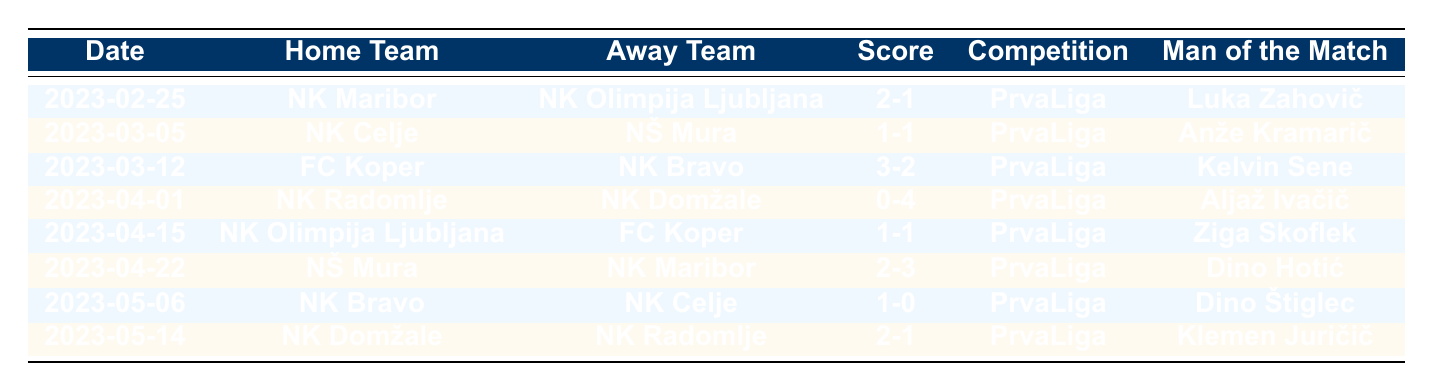What was the date of the match between NK Maribor and NK Olimpija Ljubljana? The specific match took place on 2023-02-25, as indicated in the table under the Date column for that row.
Answer: 2023-02-25 Who scored the most goals in a single match, and what was the score? The highest score was in the match between FC Koper and NK Bravo, where FC Koper won 3-2 on 2023-03-12. This is noted in the Score column for that match.
Answer: 3-2 Which team did NK Radomlje play against on April 1, 2023? According to the table, NK Radomlje played against NK Domžale on that date, as shown in the Home Team and Away Team columns of the relevant row.
Answer: NK Domžale How many matches ended in a draw? By tallying the matches where the Home Goals equaled the Away Goals, it is observed that there were 2 draws: one occurred between NK Celje and NŠ Mura, and the other between NK Olimpija Ljubljana and FC Koper, as noted in the Score column.
Answer: 2 Which player was named Man of the Match when NK Bravo played against NK Celje? From the table, it states that the Man of the Match for the NK Bravo vs. NK Celje game was Dino Štiglec, listed in the corresponding row's Man of the Match column.
Answer: Dino Štiglec What was the total number of goals scored by NK Maribor in matches listed? Adding NK Maribor's goals from two matches: 2 goals against NK Olimpija Ljubljana and 3 goals against NŠ Mura gives a total of 5 goals.
Answer: 5 Did NK Olimpija Ljubljana win any matches in this table? Looking through the match results for NK Olimpija Ljubljana, they did not win; their only match listed was a loss to NK Maribor and a draw with FC Koper. Thus, the answer is no.
Answer: No How many teams scored more than 2 goals in a match? Checking the table reveals that FC Koper (3 goals) and NK Domžale (4 goals) are the only teams to score more than 2 goals in their matches, making it a total of 2 occurrences.
Answer: 2 What is the average goals scored by away teams in the given matches? Summing all away goals (1 + 1 + 2 + 4 + 1 + 3 + 0 + 1 = 13) and dividing by 8 match occurrences results in an average of 13/8, which equals 1.625.
Answer: 1.625 Which team had the highest score and what was that score, and against whom was it achieved? The highest score was 4 goals by NK Domžale against NK Radomlje, achieved on April 1, 2023. This is indicated in the Score column highlighting the result (0-4) for that match.
Answer: NK Domžale, 4-0 against NK Radomlje 